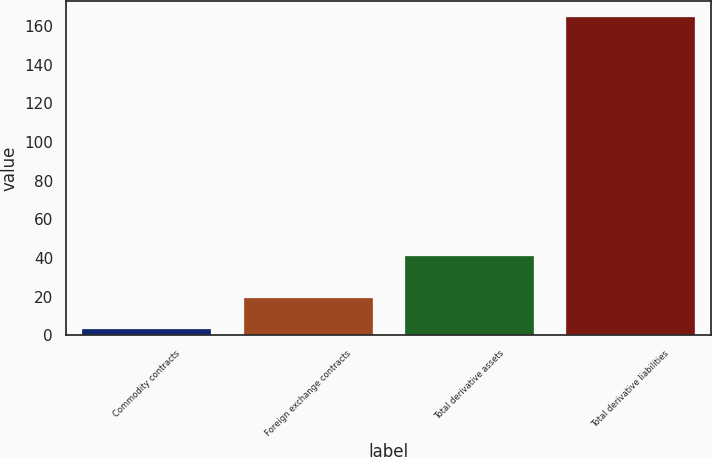Convert chart to OTSL. <chart><loc_0><loc_0><loc_500><loc_500><bar_chart><fcel>Commodity contracts<fcel>Foreign exchange contracts<fcel>Total derivative assets<fcel>Total derivative liabilities<nl><fcel>3<fcel>19.2<fcel>41<fcel>165<nl></chart> 